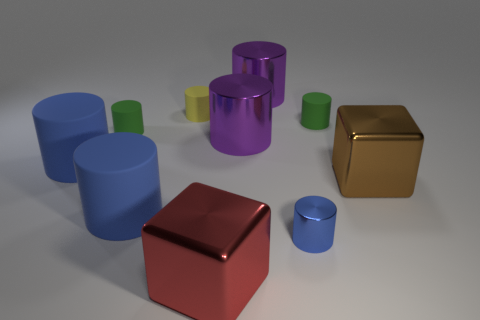There is a blue cylinder on the right side of the yellow rubber thing; does it have the same size as the matte cylinder in front of the large brown metallic cube?
Keep it short and to the point. No. What is the thing that is both left of the brown block and on the right side of the small blue metallic thing made of?
Provide a short and direct response. Rubber. Are there any other things that are the same color as the tiny shiny object?
Keep it short and to the point. Yes. Are there fewer shiny things that are to the left of the big red shiny object than yellow cylinders?
Your response must be concise. Yes. Are there more yellow cylinders than tiny blue rubber objects?
Ensure brevity in your answer.  Yes. There is a purple cylinder behind the rubber cylinder that is right of the yellow thing; is there a yellow object that is behind it?
Keep it short and to the point. No. What number of other objects are there of the same size as the yellow thing?
Your response must be concise. 3. There is a brown metal cube; are there any cylinders in front of it?
Offer a terse response. Yes. There is a tiny metal object; does it have the same color as the large cylinder in front of the large brown metallic thing?
Give a very brief answer. Yes. The block that is behind the big blue cylinder that is to the right of the tiny green cylinder that is on the left side of the red metal block is what color?
Your response must be concise. Brown. 